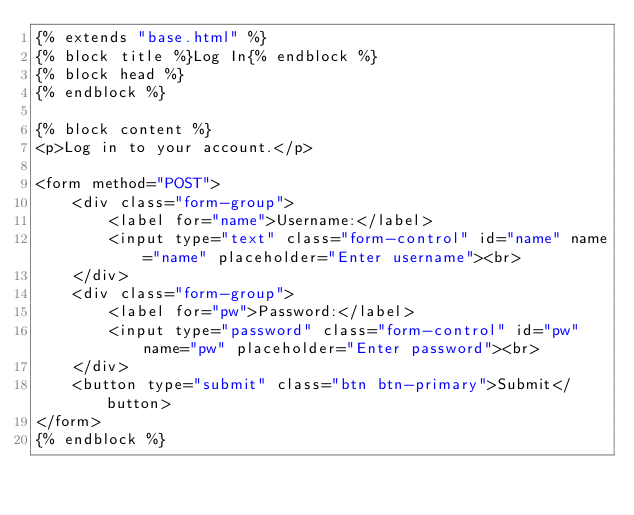<code> <loc_0><loc_0><loc_500><loc_500><_HTML_>{% extends "base.html" %} 
{% block title %}Log In{% endblock %}
{% block head %} 
{% endblock %}

{% block content %}
<p>Log in to your account.</p>

<form method="POST">
    <div class="form-group">
        <label for="name">Username:</label>
        <input type="text" class="form-control" id="name" name="name" placeholder="Enter username"><br> 
    </div>
    <div class="form-group">
        <label for="pw">Password:</label>
        <input type="password" class="form-control" id="pw" name="pw" placeholder="Enter password"><br> 
    </div>
    <button type="submit" class="btn btn-primary">Submit</button>
</form>
{% endblock %}</code> 